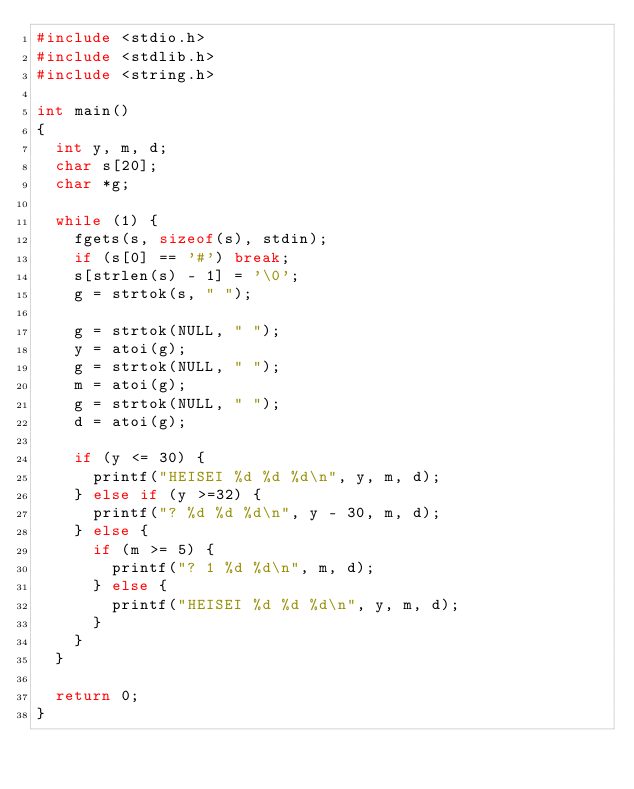<code> <loc_0><loc_0><loc_500><loc_500><_C_>#include <stdio.h>
#include <stdlib.h>
#include <string.h>

int main()
{
  int y, m, d;
  char s[20];
  char *g;
  
  while (1) {
    fgets(s, sizeof(s), stdin);
    if (s[0] == '#') break;
    s[strlen(s) - 1] = '\0';
    g = strtok(s, " ");
    
    g = strtok(NULL, " ");
    y = atoi(g);
    g = strtok(NULL, " ");
    m = atoi(g);
    g = strtok(NULL, " ");
    d = atoi(g);

    if (y <= 30) {
      printf("HEISEI %d %d %d\n", y, m, d);
    } else if (y >=32) {
      printf("? %d %d %d\n", y - 30, m, d);
    } else {
      if (m >= 5) {
        printf("? 1 %d %d\n", m, d);
      } else {
        printf("HEISEI %d %d %d\n", y, m, d);
      }
    }
  }

  return 0;
}

</code> 